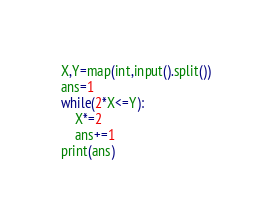Convert code to text. <code><loc_0><loc_0><loc_500><loc_500><_Python_>X,Y=map(int,input().split())
ans=1
while(2*X<=Y):
    X*=2
    ans+=1
print(ans)
</code> 